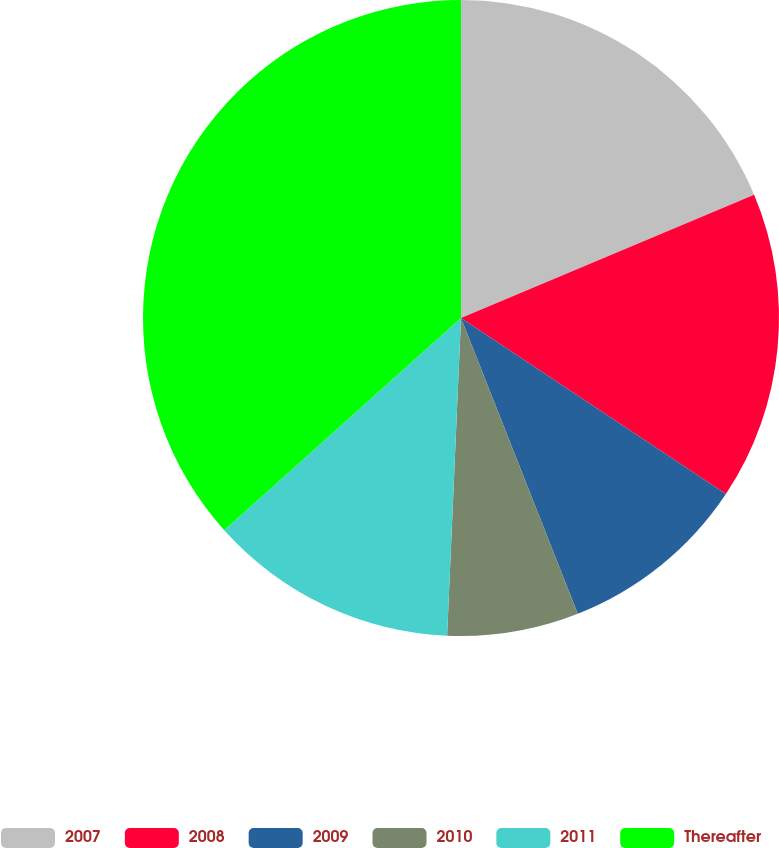Convert chart to OTSL. <chart><loc_0><loc_0><loc_500><loc_500><pie_chart><fcel>2007<fcel>2008<fcel>2009<fcel>2010<fcel>2011<fcel>Thereafter<nl><fcel>18.66%<fcel>15.67%<fcel>9.68%<fcel>6.68%<fcel>12.67%<fcel>36.63%<nl></chart> 